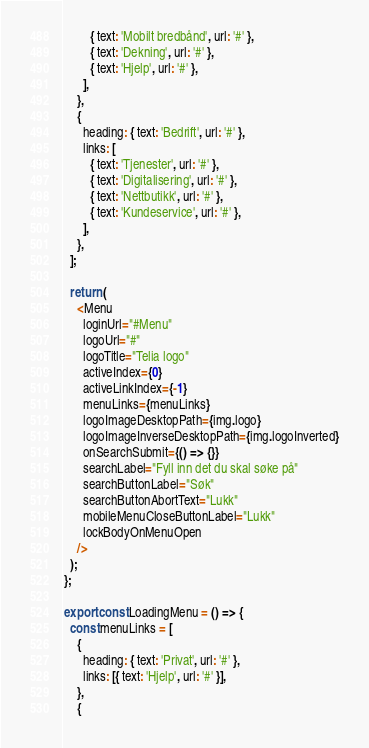<code> <loc_0><loc_0><loc_500><loc_500><_TypeScript_>        { text: 'Mobilt bredbånd', url: '#' },
        { text: 'Dekning', url: '#' },
        { text: 'Hjelp', url: '#' },
      ],
    },
    {
      heading: { text: 'Bedrift', url: '#' },
      links: [
        { text: 'Tjenester', url: '#' },
        { text: 'Digitalisering', url: '#' },
        { text: 'Nettbutikk', url: '#' },
        { text: 'Kundeservice', url: '#' },
      ],
    },
  ];

  return (
    <Menu
      loginUrl="#Menu"
      logoUrl="#"
      logoTitle="Telia logo"
      activeIndex={0}
      activeLinkIndex={-1}
      menuLinks={menuLinks}
      logoImageDesktopPath={img.logo}
      logoImageInverseDesktopPath={img.logoInverted}
      onSearchSubmit={() => {}}
      searchLabel="Fyll inn det du skal søke på"
      searchButtonLabel="Søk"
      searchButtonAbortText="Lukk"
      mobileMenuCloseButtonLabel="Lukk"
      lockBodyOnMenuOpen
    />
  );
};

export const LoadingMenu = () => {
  const menuLinks = [
    {
      heading: { text: 'Privat', url: '#' },
      links: [{ text: 'Hjelp', url: '#' }],
    },
    {</code> 